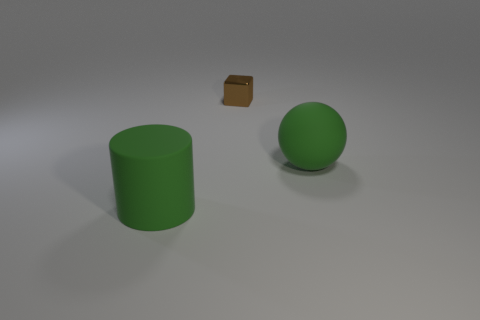Add 1 green objects. How many objects exist? 4 Subtract all spheres. How many objects are left? 2 Add 2 brown objects. How many brown objects are left? 3 Add 1 red matte objects. How many red matte objects exist? 1 Subtract 0 purple cylinders. How many objects are left? 3 Subtract all brown shiny things. Subtract all tiny cylinders. How many objects are left? 2 